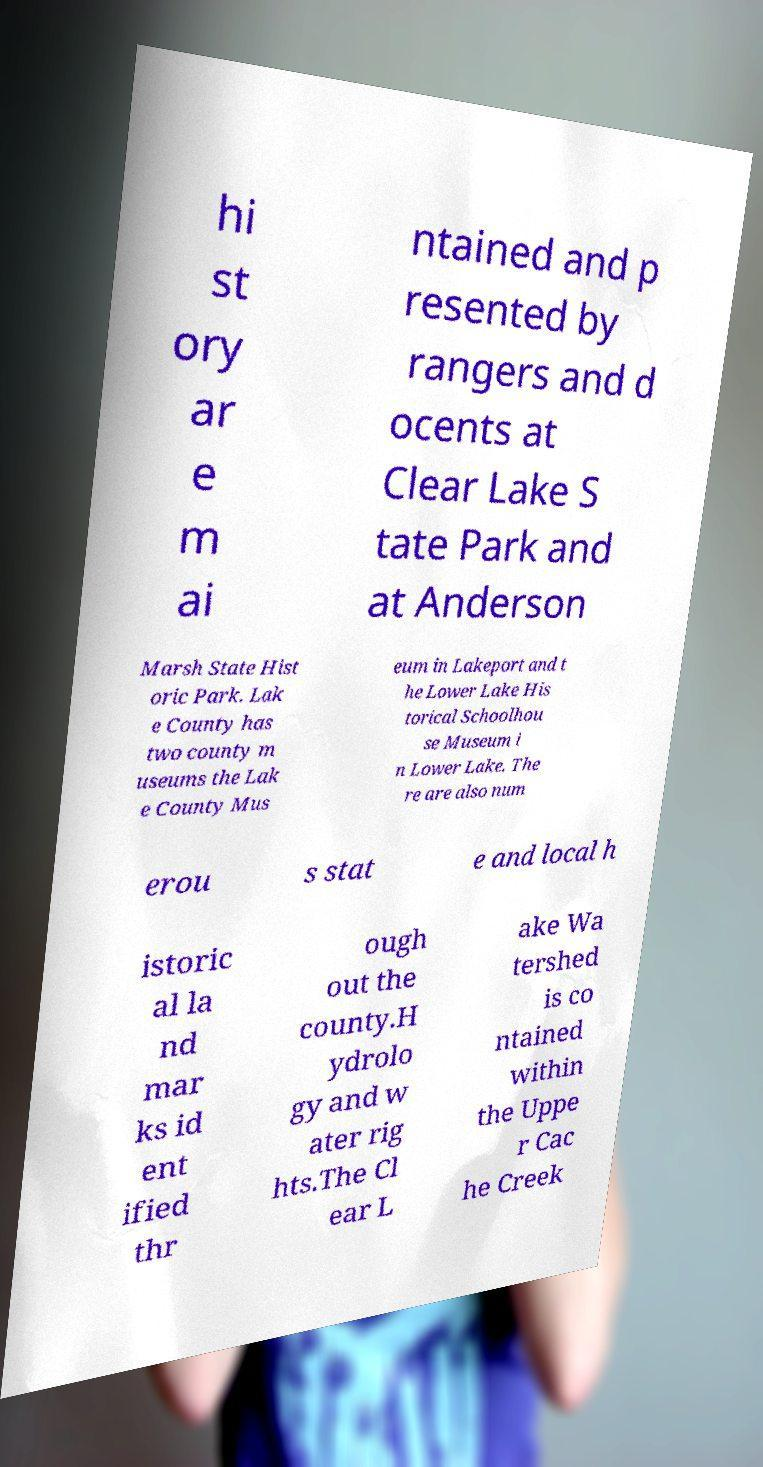Could you assist in decoding the text presented in this image and type it out clearly? hi st ory ar e m ai ntained and p resented by rangers and d ocents at Clear Lake S tate Park and at Anderson Marsh State Hist oric Park. Lak e County has two county m useums the Lak e County Mus eum in Lakeport and t he Lower Lake His torical Schoolhou se Museum i n Lower Lake. The re are also num erou s stat e and local h istoric al la nd mar ks id ent ified thr ough out the county.H ydrolo gy and w ater rig hts.The Cl ear L ake Wa tershed is co ntained within the Uppe r Cac he Creek 